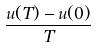Convert formula to latex. <formula><loc_0><loc_0><loc_500><loc_500>\frac { u ( T ) - u ( 0 ) } { T }</formula> 